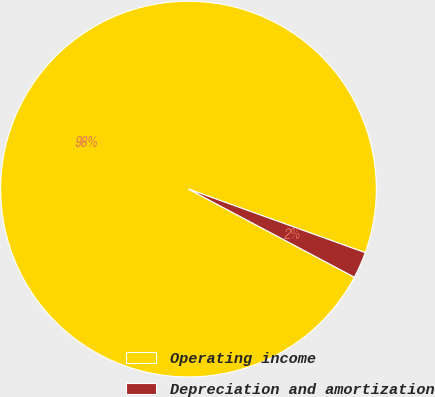Convert chart. <chart><loc_0><loc_0><loc_500><loc_500><pie_chart><fcel>Operating income<fcel>Depreciation and amortization<nl><fcel>97.73%<fcel>2.27%<nl></chart> 